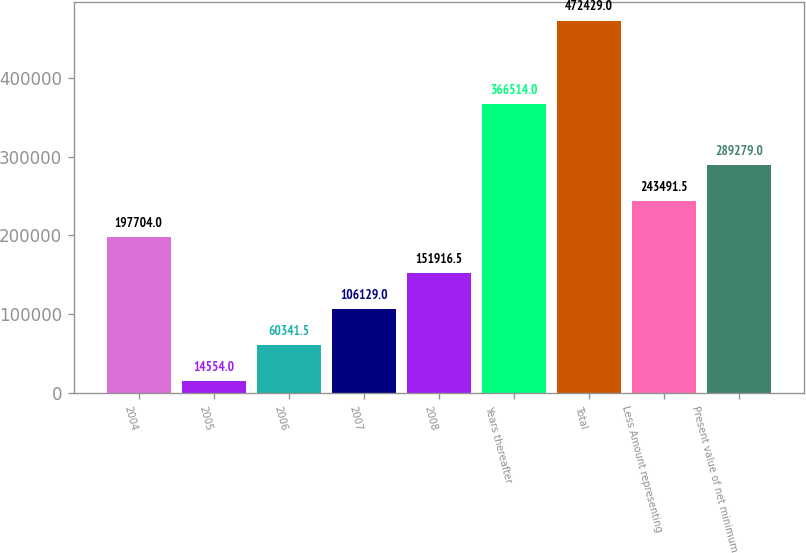Convert chart. <chart><loc_0><loc_0><loc_500><loc_500><bar_chart><fcel>2004<fcel>2005<fcel>2006<fcel>2007<fcel>2008<fcel>Years thereafter<fcel>Total<fcel>Less Amount representing<fcel>Present value of net minimum<nl><fcel>197704<fcel>14554<fcel>60341.5<fcel>106129<fcel>151916<fcel>366514<fcel>472429<fcel>243492<fcel>289279<nl></chart> 